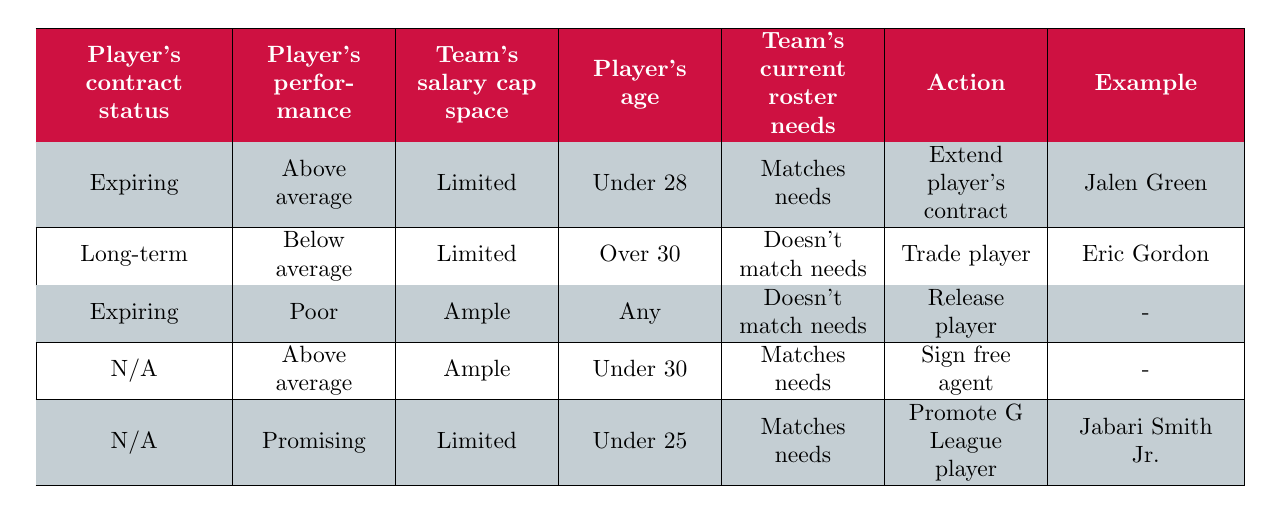What action is recommended for a player who has an expiring contract and is above average in performance? According to the table, for a player with an "Expiring" contract status and "Above average" performance, the action would be to "Extend player's contract." This is directly referenced in the first row of the table.
Answer: Extend player's contract For a player who is older than 30, has a long-term contract and below average performance, which action is suggested? The table indicates that if a player is "Long-term," "Below average," and over 30 years old, the recommended action is to "Trade player." This can be found in the second row of the table.
Answer: Trade player Is it true that a player with poor performance and an ample salary cap should be released? The third row of the table indicates that if a player has "Poor" performance and the team has "Ample" salary cap space, the action suggested is to "Release player." Therefore, this statement is true.
Answer: Yes How many players in the examples have an expiring contract and meet the team's current roster needs? The only player listed with an "Expiring" contract status who meets the team's needs is Jalen Green (above average performance and matches needs). Therefore, there is only one player fulfilling these conditions.
Answer: 1 If a player is promising and under 25 with limited salary cap space, what action should be taken? Referring to the fifth rule in the table, it states that a player who is "Promising," "Under 25," and with "Limited" salary cap space should be "Promoted to G League." Hence, this is the action that should be taken.
Answer: Promote G League player Are there any players listed who should be signed as free agents based on the table? The table shows that there is no specific mention of any players who can be signed as free agents in the examples, as the relevant row does not point to a specific player. Hence, there are no players listed for signing as free agents.
Answer: No How is the action determined if a player's contract status is "N/A" and their performance is above average? In the case of a player with contract status "N/A" and "Above average" performance, the table suggests they could be signed as a free agent if the salary cap is "Ample" and the team’s current needs "Match." However, no specific player meets all these conditions for action.
Answer: Sign free agent 